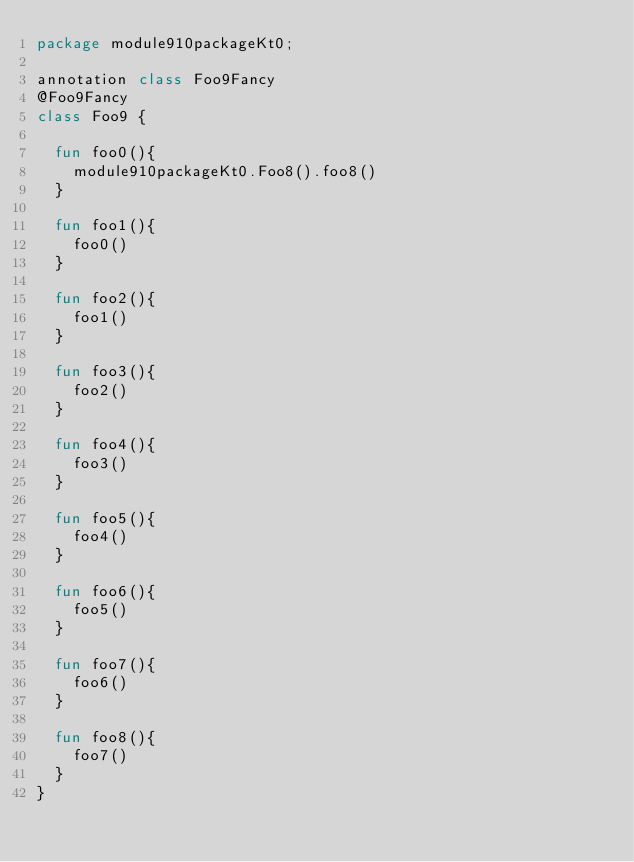<code> <loc_0><loc_0><loc_500><loc_500><_Kotlin_>package module910packageKt0;

annotation class Foo9Fancy
@Foo9Fancy
class Foo9 {

  fun foo0(){
    module910packageKt0.Foo8().foo8()
  }

  fun foo1(){
    foo0()
  }

  fun foo2(){
    foo1()
  }

  fun foo3(){
    foo2()
  }

  fun foo4(){
    foo3()
  }

  fun foo5(){
    foo4()
  }

  fun foo6(){
    foo5()
  }

  fun foo7(){
    foo6()
  }

  fun foo8(){
    foo7()
  }
}</code> 